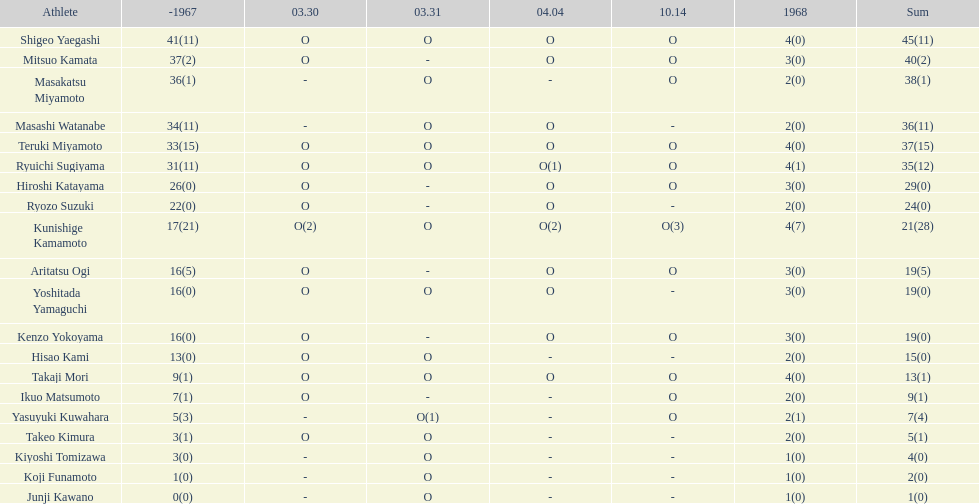Who had more points takaji mori or junji kawano? Takaji Mori. Parse the full table. {'header': ['Athlete', '-1967', '03.30', '03.31', '04.04', '10.14', '1968', 'Sum'], 'rows': [['Shigeo Yaegashi', '41(11)', 'O', 'O', 'O', 'O', '4(0)', '45(11)'], ['Mitsuo Kamata', '37(2)', 'O', '-', 'O', 'O', '3(0)', '40(2)'], ['Masakatsu Miyamoto', '36(1)', '-', 'O', '-', 'O', '2(0)', '38(1)'], ['Masashi Watanabe', '34(11)', '-', 'O', 'O', '-', '2(0)', '36(11)'], ['Teruki Miyamoto', '33(15)', 'O', 'O', 'O', 'O', '4(0)', '37(15)'], ['Ryuichi Sugiyama', '31(11)', 'O', 'O', 'O(1)', 'O', '4(1)', '35(12)'], ['Hiroshi Katayama', '26(0)', 'O', '-', 'O', 'O', '3(0)', '29(0)'], ['Ryozo Suzuki', '22(0)', 'O', '-', 'O', '-', '2(0)', '24(0)'], ['Kunishige Kamamoto', '17(21)', 'O(2)', 'O', 'O(2)', 'O(3)', '4(7)', '21(28)'], ['Aritatsu Ogi', '16(5)', 'O', '-', 'O', 'O', '3(0)', '19(5)'], ['Yoshitada Yamaguchi', '16(0)', 'O', 'O', 'O', '-', '3(0)', '19(0)'], ['Kenzo Yokoyama', '16(0)', 'O', '-', 'O', 'O', '3(0)', '19(0)'], ['Hisao Kami', '13(0)', 'O', 'O', '-', '-', '2(0)', '15(0)'], ['Takaji Mori', '9(1)', 'O', 'O', 'O', 'O', '4(0)', '13(1)'], ['Ikuo Matsumoto', '7(1)', 'O', '-', '-', 'O', '2(0)', '9(1)'], ['Yasuyuki Kuwahara', '5(3)', '-', 'O(1)', '-', 'O', '2(1)', '7(4)'], ['Takeo Kimura', '3(1)', 'O', 'O', '-', '-', '2(0)', '5(1)'], ['Kiyoshi Tomizawa', '3(0)', '-', 'O', '-', '-', '1(0)', '4(0)'], ['Koji Funamoto', '1(0)', '-', 'O', '-', '-', '1(0)', '2(0)'], ['Junji Kawano', '0(0)', '-', 'O', '-', '-', '1(0)', '1(0)']]} 